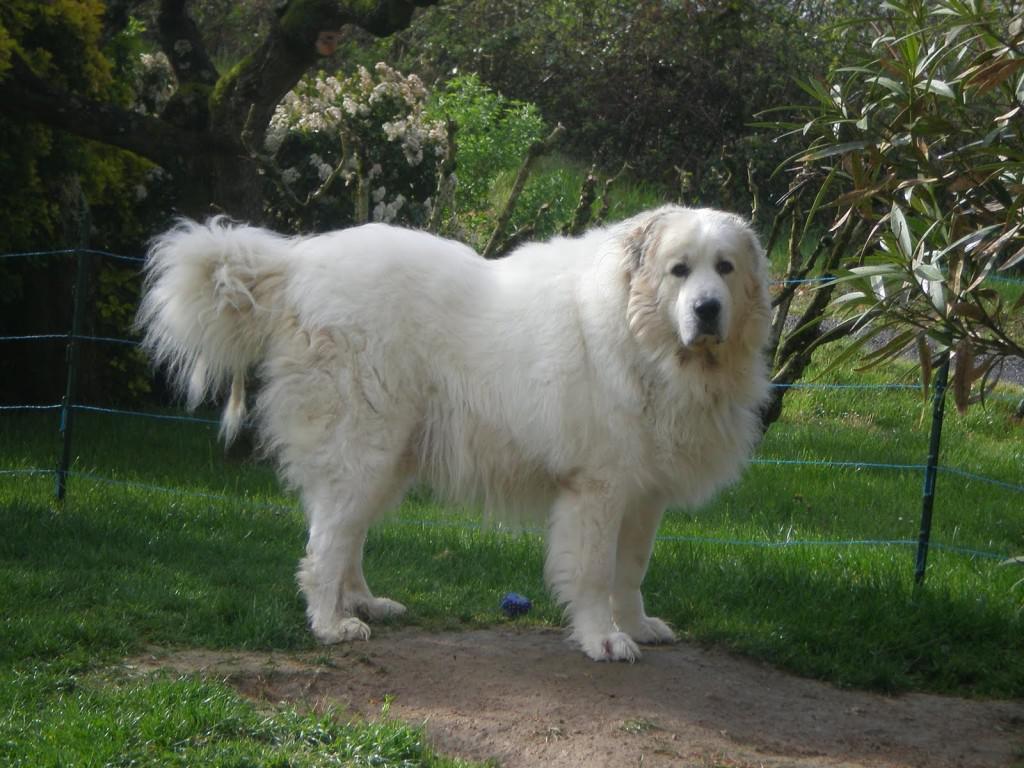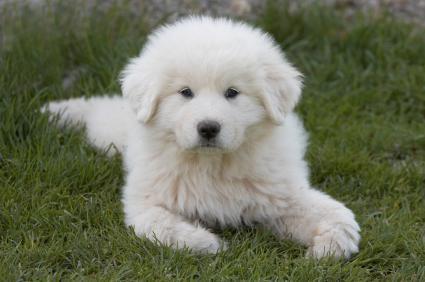The first image is the image on the left, the second image is the image on the right. Analyze the images presented: Is the assertion "One image shows an adult white dog standing on all fours in a grassy area." valid? Answer yes or no. Yes. The first image is the image on the left, the second image is the image on the right. Considering the images on both sides, is "A single white dog is laying on the grass in the image on the right." valid? Answer yes or no. Yes. 